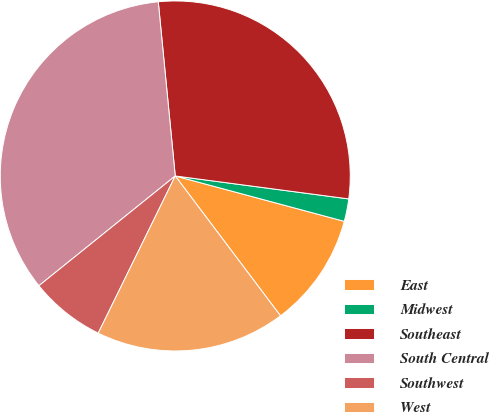Convert chart to OTSL. <chart><loc_0><loc_0><loc_500><loc_500><pie_chart><fcel>East<fcel>Midwest<fcel>Southeast<fcel>South Central<fcel>Southwest<fcel>West<nl><fcel>10.56%<fcel>2.08%<fcel>28.64%<fcel>34.24%<fcel>6.96%<fcel>17.52%<nl></chart> 